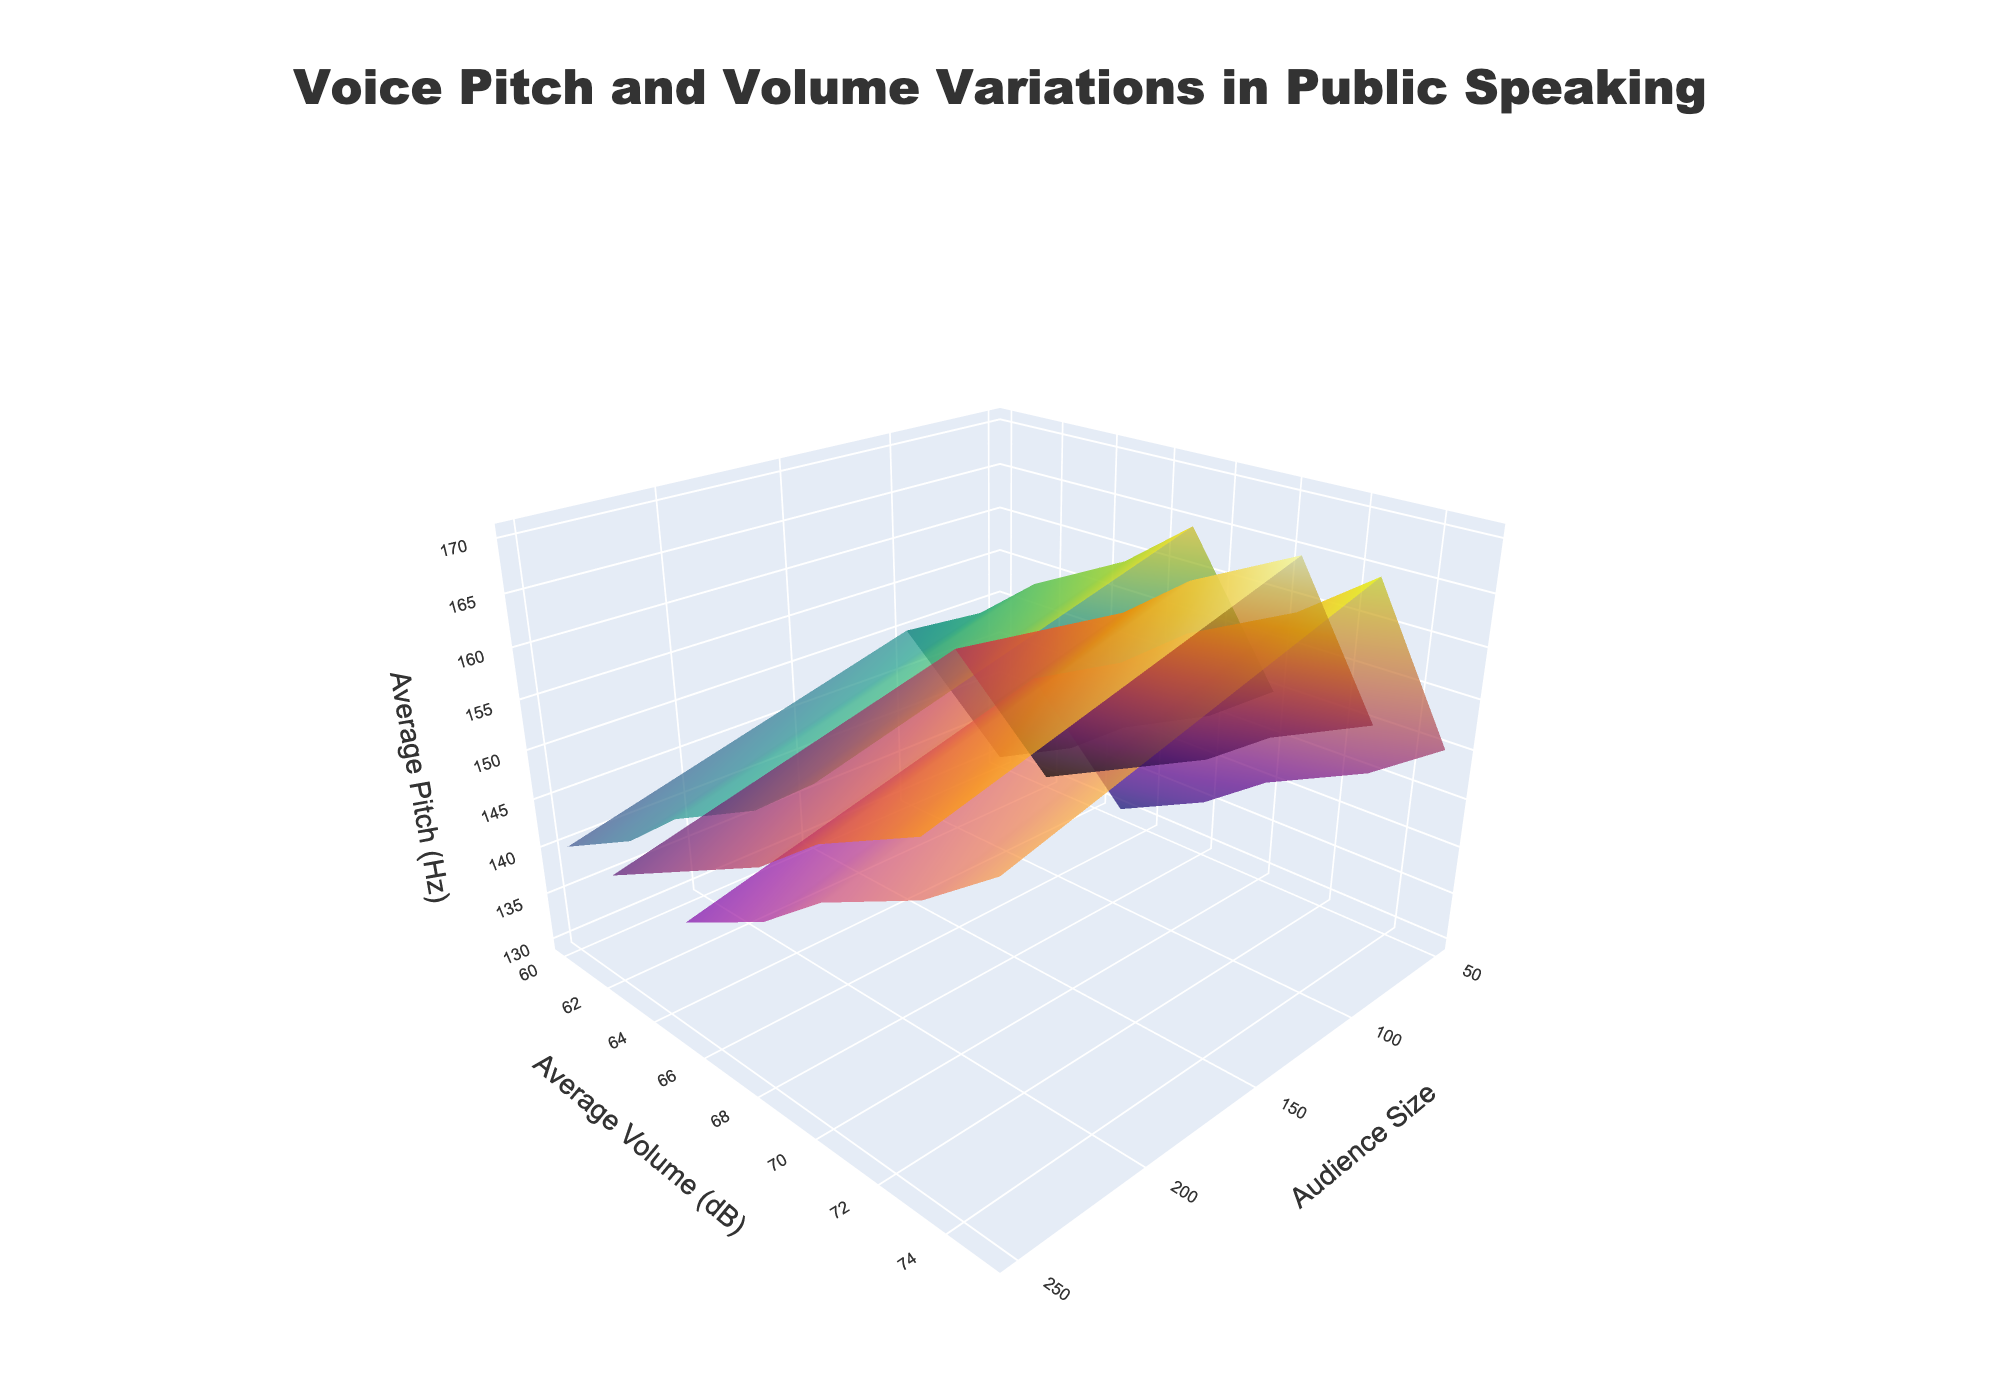How many audience sizes are represented in the plot? The plot shows various audience sizes. By inspecting the x-axis and the gridlines corresponding to the data points, we see that there are audience sizes of 50, 100, 250, 500, and 1000.
Answer: 5 What does each surface plot represent? There are three surface plots differentiated by color scales. Each surface plot represents a different speaking style: Motivational, Informative, and Persuasive.
Answer: Speaking styles Which speaking style shows the highest average pitch at an audience size of 1000? By examining the peaks of the surface plots at the audience size of 1000, the Motivational speaking style has the highest average pitch.
Answer: Motivational How does the average volume change with increasing audience size for the Informative speaking style? Trace the corresponding surface plot for Informative speaking style and check the trend from the smallest to the largest audience size. The average volume increases as the audience size increases.
Answer: Increases What is the difference in average pitch between the Persuasive and Informative styles for an audience size of 500? Check the values on the z-axis for both speaking styles at an audience size of 500. For Persuasive it's 155 Hz, and for Informative it's 145 Hz. The difference is 155 - 145.
Answer: 10 Hz Compare the average volume of the Motivational style to the Informative style for an audience size of 250. Which one is louder? Locate the average volume values on the y-axis for both speaking styles at an audience size of 250. For Motivational it's 70 dB, and for Informative it's 65 dB. Thus, the Motivational style is louder.
Answer: Motivational What's the trend in average pitch for the Persuasive style as the audience size increases from 50 to 1000? Analyze the highest points on the surface plot for Persuasive at different audience sizes. The average pitch increases consistently from 140 Hz at audience size 50 to 160 Hz at audience size 1000.
Answer: Increases Do all speaking styles show an increase in average volume with increasing audience size? Check the surface plots for the Motivational, Informative, and Persuasive styles as the audience size increases. All three show an increasing trend in average volume over increasing audience sizes.
Answer: Yes What is the average volume of the Persuasive style at an audience size of 50? Identify the corresponding point on the y-axis for the Persuasive style at an audience size of 50. The value is 62 dB.
Answer: 62 dB How do the trends in average pitch and volume differ between Motivational and Persuasive styles? Compare the surface plots for both styles. The Motivational style shows a higher increase in both pitch and volume with increasing audience size compared to the Persuasive style, but both show an upward trend.
Answer: Motivational has a higher increase 